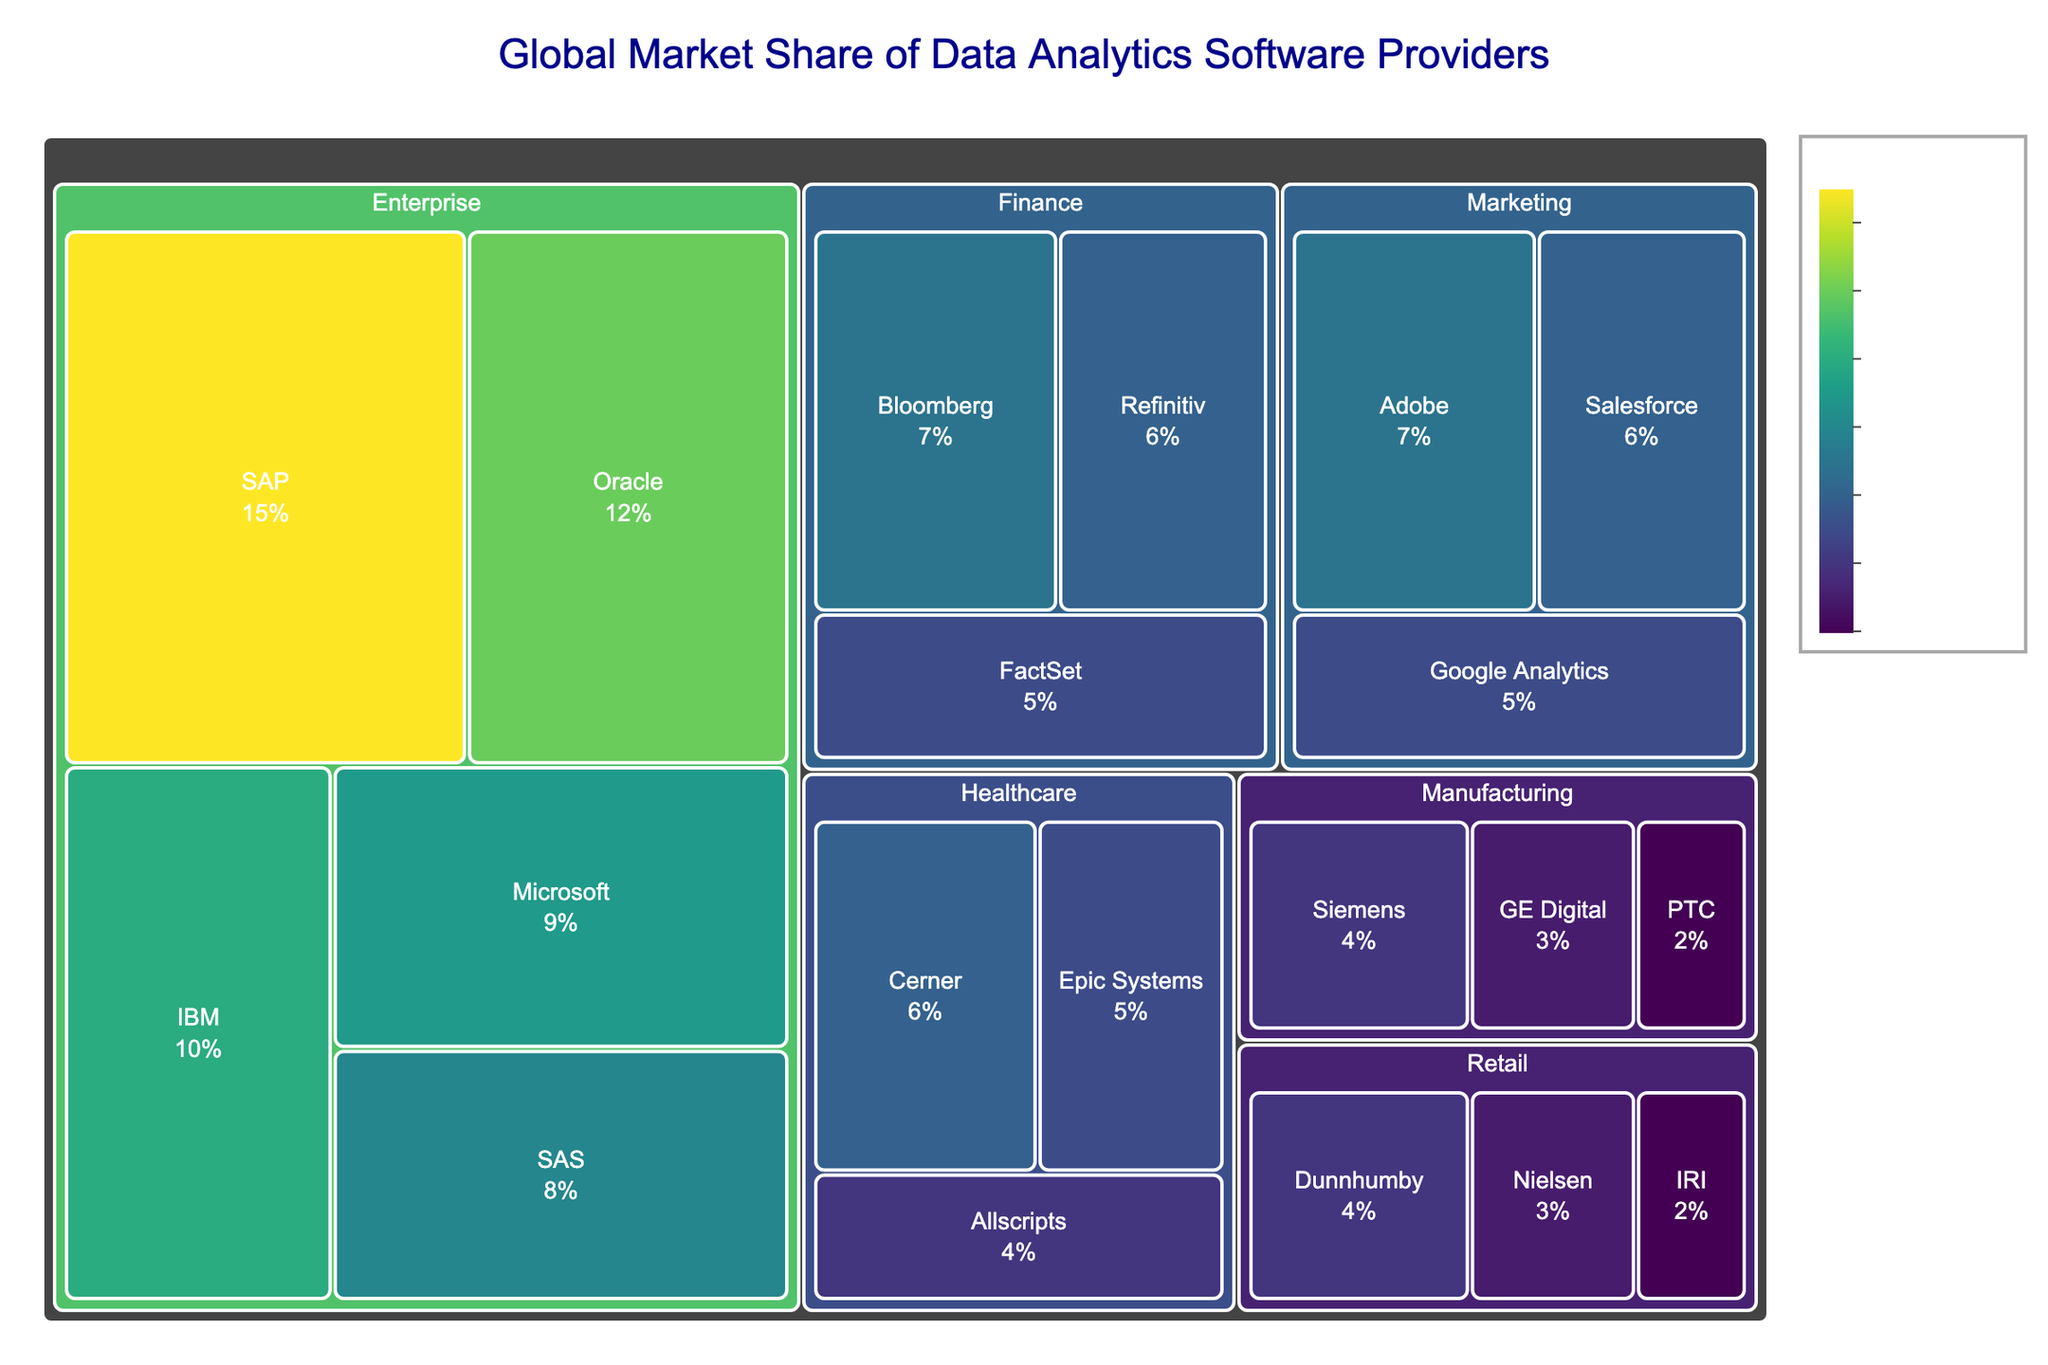What's the title of the figure? The title is displayed at the top of the figure to indicate what the treemap is about.
Answer: Global Market Share of Data Analytics Software Providers Which subcategory within the Enterprise category has the highest market share? Look at the blocks under the Enterprise category and identify the one with the largest area.
Answer: SAP What's the combined market share of SAP and Microsoft in the Enterprise category? Add the values of SAP (15) and Microsoft (9) from the blocks within the Enterprise category. 15 + 9 = 24
Answer: 24% Which category has the smallest cumulative market share of its subcategories? Sum the values of subcategories within each category and compare the totals. Retail has 4+3+2=9, which is the smallest among all categories.
Answer: Retail Which data analytics provider has the largest market share in the Healthcare category? Look at the blocks under the Healthcare category and identify the one with the largest area.
Answer: Cerner Is the market share of Adobe in the Marketing category greater than the market share of Cerner in the Healthcare category? Compare the values of Adobe (7) from Marketing and Cerner (6) from Healthcare.
Answer: Yes What's the average market share of the subcategories within the Finance category? Add the values of subcategories in Finance: 7 + 6 + 5 = 18, then divide by the number of subcategories (3). 18/3 = 6
Answer: 6% Which subcategory has the smallest market share within the Manufacturing category? Identify the block with the smallest area within Manufacturing.
Answer: PTC Which category has more subcategories: Retail or Healthcare? Count the number of blocks under each category. Retail has 3 subcategories, and Healthcare has 3 subcategories.
Answer: They are equal What is the market share difference between SAP in the Enterprise category and Bloomberg in the Finance category? Subtract the market share of Bloomberg (7) from the market share of SAP (15). 15 - 7 = 8
Answer: 8% 